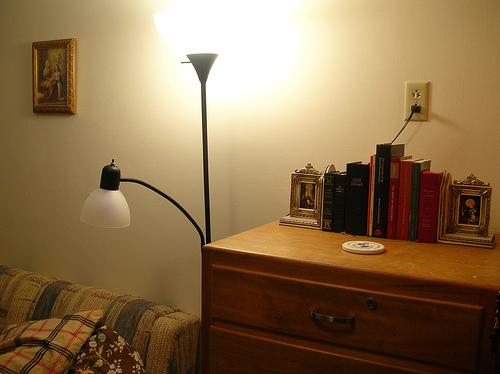<image>
Can you confirm if the pillow is on the sofa? Yes. Looking at the image, I can see the pillow is positioned on top of the sofa, with the sofa providing support. Is there a photo on the wall? Yes. Looking at the image, I can see the photo is positioned on top of the wall, with the wall providing support. Is the picture on the drawers? No. The picture is not positioned on the drawers. They may be near each other, but the picture is not supported by or resting on top of the drawers. 